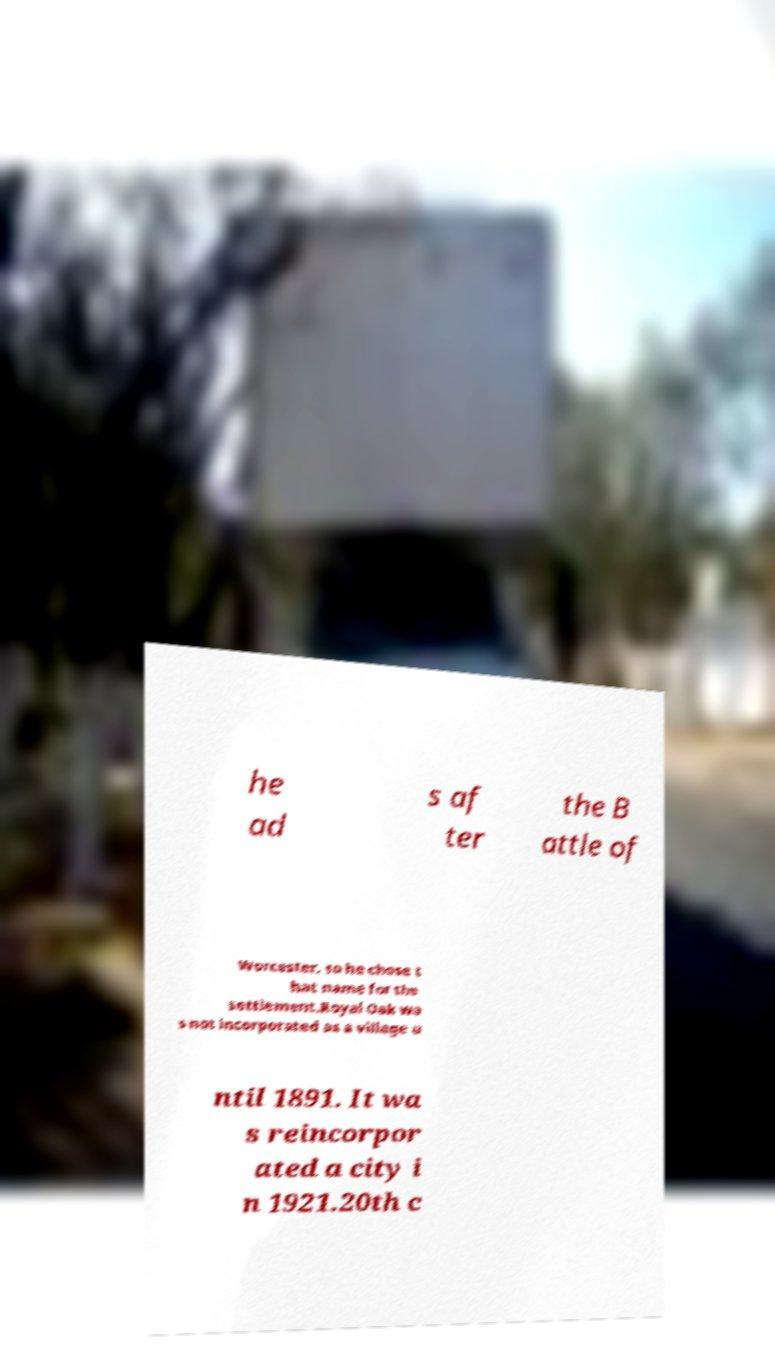Please identify and transcribe the text found in this image. he ad s af ter the B attle of Worcester, so he chose t hat name for the settlement.Royal Oak wa s not incorporated as a village u ntil 1891. It wa s reincorpor ated a city i n 1921.20th c 